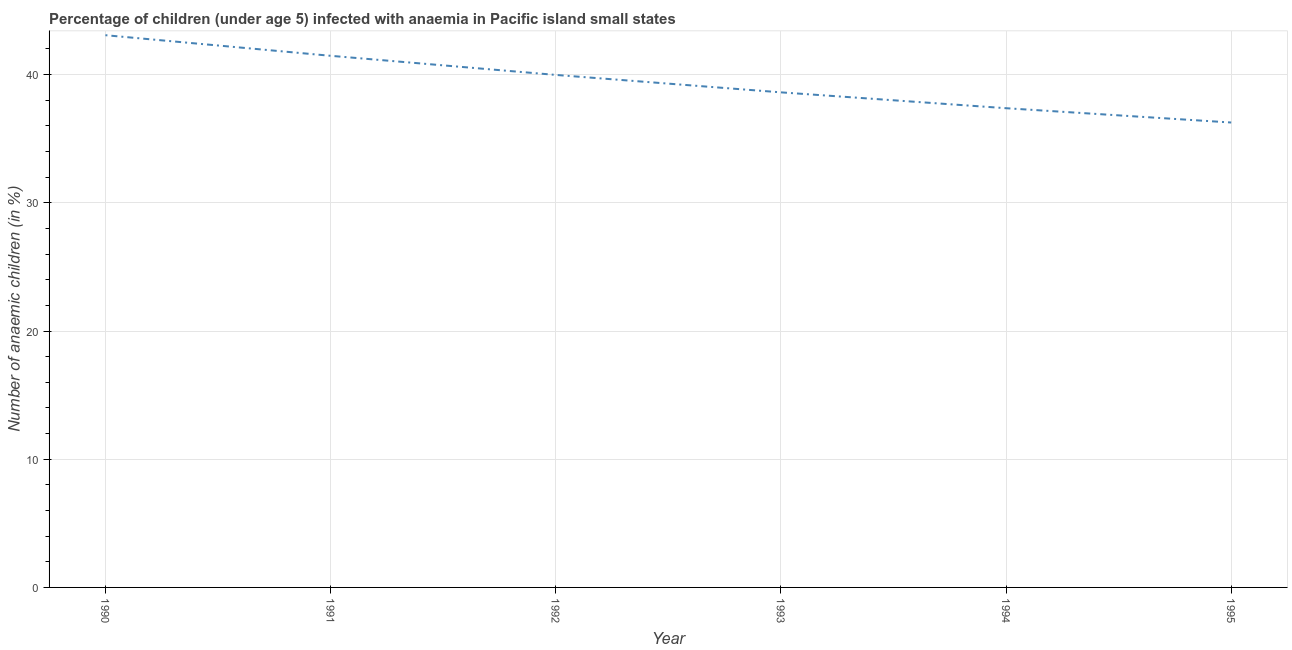What is the number of anaemic children in 1994?
Your response must be concise. 37.38. Across all years, what is the maximum number of anaemic children?
Keep it short and to the point. 43.07. Across all years, what is the minimum number of anaemic children?
Offer a very short reply. 36.26. In which year was the number of anaemic children maximum?
Give a very brief answer. 1990. In which year was the number of anaemic children minimum?
Your response must be concise. 1995. What is the sum of the number of anaemic children?
Make the answer very short. 236.77. What is the difference between the number of anaemic children in 1991 and 1992?
Provide a succinct answer. 1.49. What is the average number of anaemic children per year?
Give a very brief answer. 39.46. What is the median number of anaemic children?
Ensure brevity in your answer.  39.3. In how many years, is the number of anaemic children greater than 6 %?
Ensure brevity in your answer.  6. Do a majority of the years between 1994 and 1991 (inclusive) have number of anaemic children greater than 6 %?
Keep it short and to the point. Yes. What is the ratio of the number of anaemic children in 1990 to that in 1992?
Give a very brief answer. 1.08. Is the number of anaemic children in 1991 less than that in 1992?
Your answer should be very brief. No. What is the difference between the highest and the second highest number of anaemic children?
Ensure brevity in your answer.  1.61. Is the sum of the number of anaemic children in 1992 and 1995 greater than the maximum number of anaemic children across all years?
Keep it short and to the point. Yes. What is the difference between the highest and the lowest number of anaemic children?
Ensure brevity in your answer.  6.81. In how many years, is the number of anaemic children greater than the average number of anaemic children taken over all years?
Keep it short and to the point. 3. Does the number of anaemic children monotonically increase over the years?
Offer a very short reply. No. How many lines are there?
Make the answer very short. 1. What is the difference between two consecutive major ticks on the Y-axis?
Your response must be concise. 10. Are the values on the major ticks of Y-axis written in scientific E-notation?
Make the answer very short. No. Does the graph contain any zero values?
Give a very brief answer. No. What is the title of the graph?
Your answer should be compact. Percentage of children (under age 5) infected with anaemia in Pacific island small states. What is the label or title of the Y-axis?
Ensure brevity in your answer.  Number of anaemic children (in %). What is the Number of anaemic children (in %) of 1990?
Offer a very short reply. 43.07. What is the Number of anaemic children (in %) in 1991?
Offer a terse response. 41.47. What is the Number of anaemic children (in %) in 1992?
Provide a short and direct response. 39.98. What is the Number of anaemic children (in %) in 1993?
Provide a succinct answer. 38.62. What is the Number of anaemic children (in %) in 1994?
Offer a very short reply. 37.38. What is the Number of anaemic children (in %) in 1995?
Your response must be concise. 36.26. What is the difference between the Number of anaemic children (in %) in 1990 and 1991?
Give a very brief answer. 1.61. What is the difference between the Number of anaemic children (in %) in 1990 and 1992?
Ensure brevity in your answer.  3.1. What is the difference between the Number of anaemic children (in %) in 1990 and 1993?
Make the answer very short. 4.46. What is the difference between the Number of anaemic children (in %) in 1990 and 1994?
Give a very brief answer. 5.69. What is the difference between the Number of anaemic children (in %) in 1990 and 1995?
Offer a terse response. 6.81. What is the difference between the Number of anaemic children (in %) in 1991 and 1992?
Your answer should be very brief. 1.49. What is the difference between the Number of anaemic children (in %) in 1991 and 1993?
Your answer should be very brief. 2.85. What is the difference between the Number of anaemic children (in %) in 1991 and 1994?
Your response must be concise. 4.09. What is the difference between the Number of anaemic children (in %) in 1991 and 1995?
Provide a succinct answer. 5.2. What is the difference between the Number of anaemic children (in %) in 1992 and 1993?
Provide a succinct answer. 1.36. What is the difference between the Number of anaemic children (in %) in 1992 and 1994?
Your answer should be very brief. 2.6. What is the difference between the Number of anaemic children (in %) in 1992 and 1995?
Offer a very short reply. 3.71. What is the difference between the Number of anaemic children (in %) in 1993 and 1994?
Offer a terse response. 1.24. What is the difference between the Number of anaemic children (in %) in 1993 and 1995?
Ensure brevity in your answer.  2.35. What is the difference between the Number of anaemic children (in %) in 1994 and 1995?
Ensure brevity in your answer.  1.12. What is the ratio of the Number of anaemic children (in %) in 1990 to that in 1991?
Provide a succinct answer. 1.04. What is the ratio of the Number of anaemic children (in %) in 1990 to that in 1992?
Offer a very short reply. 1.08. What is the ratio of the Number of anaemic children (in %) in 1990 to that in 1993?
Your answer should be compact. 1.11. What is the ratio of the Number of anaemic children (in %) in 1990 to that in 1994?
Your answer should be very brief. 1.15. What is the ratio of the Number of anaemic children (in %) in 1990 to that in 1995?
Your response must be concise. 1.19. What is the ratio of the Number of anaemic children (in %) in 1991 to that in 1992?
Offer a terse response. 1.04. What is the ratio of the Number of anaemic children (in %) in 1991 to that in 1993?
Your answer should be compact. 1.07. What is the ratio of the Number of anaemic children (in %) in 1991 to that in 1994?
Offer a terse response. 1.11. What is the ratio of the Number of anaemic children (in %) in 1991 to that in 1995?
Your answer should be very brief. 1.14. What is the ratio of the Number of anaemic children (in %) in 1992 to that in 1993?
Your answer should be compact. 1.03. What is the ratio of the Number of anaemic children (in %) in 1992 to that in 1994?
Offer a terse response. 1.07. What is the ratio of the Number of anaemic children (in %) in 1992 to that in 1995?
Offer a terse response. 1.1. What is the ratio of the Number of anaemic children (in %) in 1993 to that in 1994?
Your answer should be very brief. 1.03. What is the ratio of the Number of anaemic children (in %) in 1993 to that in 1995?
Offer a terse response. 1.06. What is the ratio of the Number of anaemic children (in %) in 1994 to that in 1995?
Your answer should be compact. 1.03. 